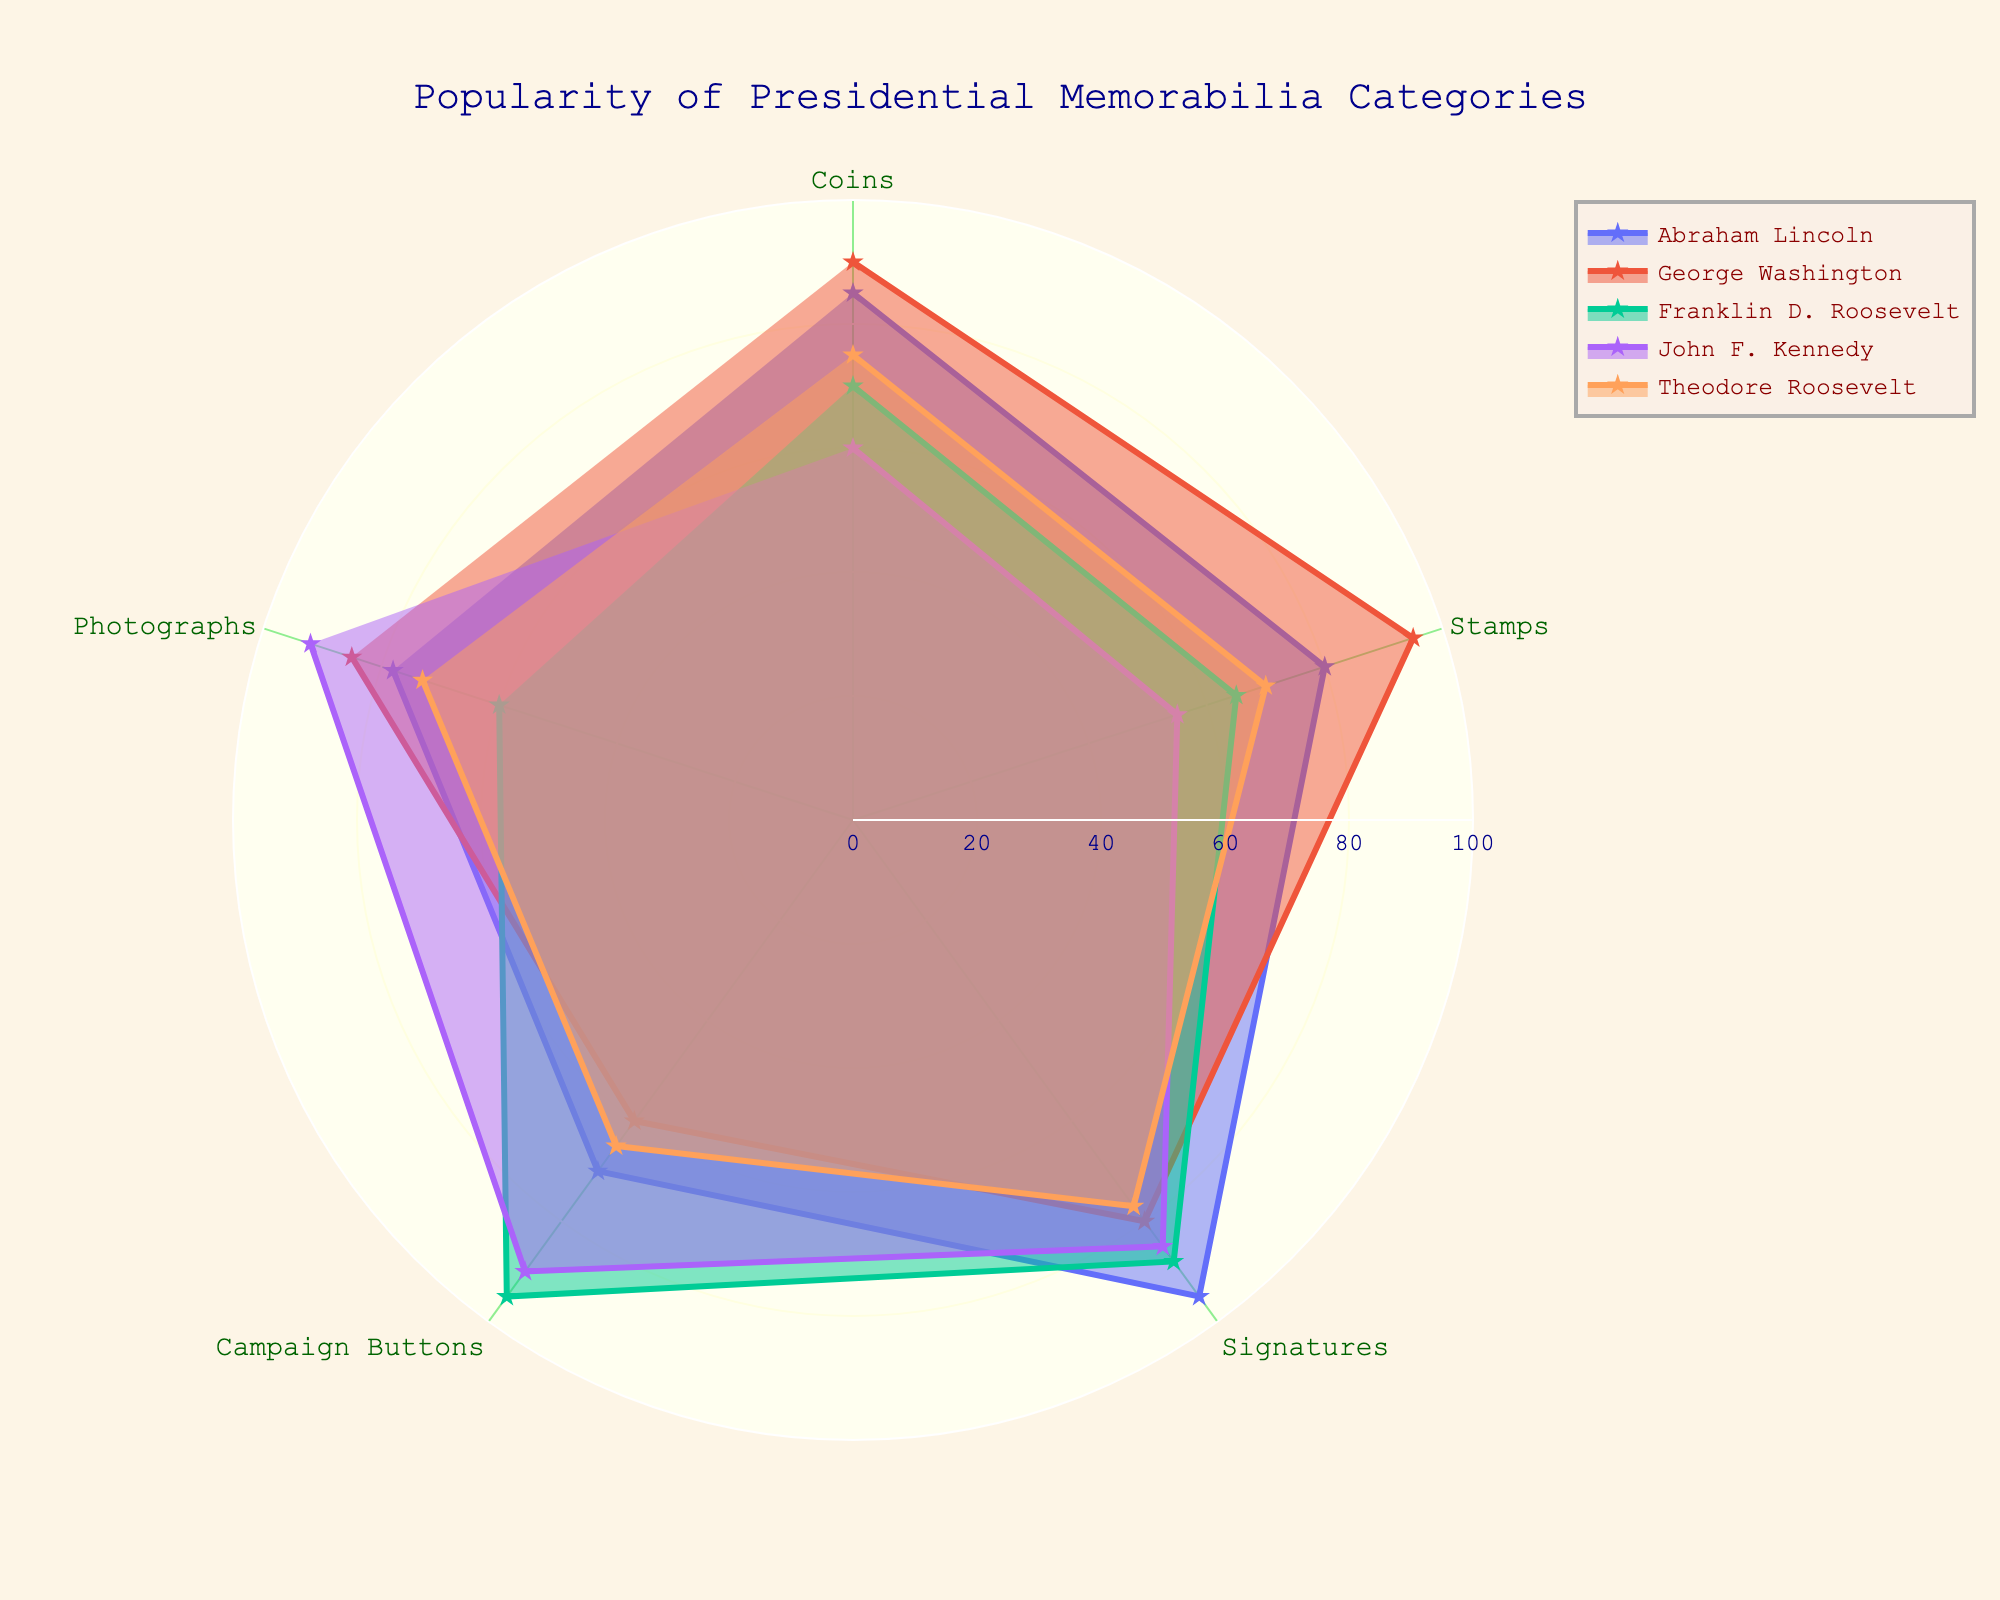What category is the least popular for Abraham Lincoln? By examining the radar chart, we can see that the line representing Abraham Lincoln is the closest to the center in the "Campaign Buttons" category, indicating this is where his memorabilia's popularity is lowest.
Answer: Campaign Buttons Which president has the highest popularity in the "Signatures" category? Looking at the "Signatures" category in the radar chart, the line that extends the furthest is for Abraham Lincoln, indicating he has the highest popularity in this category.
Answer: Abraham Lincoln What's the average popularity score for John F. Kennedy across all categories? To find the average, sum up the popularity scores of John F. Kennedy for all categories (60+55+85+90+92) which equals 382. Then divide this by the number of categories (5). 382/5 = 76.4
Answer: 76.4 Which category shows the greatest variation in popularity among the presidents? By visually inspecting the spread of values for each category, "Campaign Buttons" appears to have the widest range, with values from 60 to 95, indicating the greatest variation.
Answer: Campaign Buttons Is George Washington more popular than Theodore Roosevelt in "Coins"? By comparing the values in the "Coins" category in the radar chart, George Washington has a score of 90, and Theodore Roosevelt has a score of 75, so George Washington is more popular.
Answer: Yes Which two categories are most closely scored for Franklin D. Roosevelt? By observing the radar chart, the scores for Franklin D. Roosevelt in the "Coins" (70) and "Stamps" (65) categories are closest to each other.
Answer: Coins and Stamps What is the difference in popularity between Theodore Roosevelt's "Photographs" and "Campaign Buttons"? Theodore Roosevelt scores 73 in "Photographs" and 65 in "Campaign Buttons". The difference is 73 - 65 = 8.
Answer: 8 In which category do all the presidents have a score above 50? By checking all the categories on the radar chart, we observe that all presidents have scores above 50 in the "Coins" category.
Answer: Coins Among the presidents, who is the second most popular in "Stamps"? In the "Stamps" category, George Washington is the most popular (95), followed by Abraham Lincoln (80), making Abraham Lincoln the second most popular.
Answer: Abraham Lincoln How much more popular is Franklin D. Roosevelt in "Campaign Buttons" than Abraham Lincoln? Franklin D. Roosevelt has a score of 95 in "Campaign Buttons", and Abraham Lincoln has a score of 70. The difference is 95 - 70 = 25.
Answer: 25 